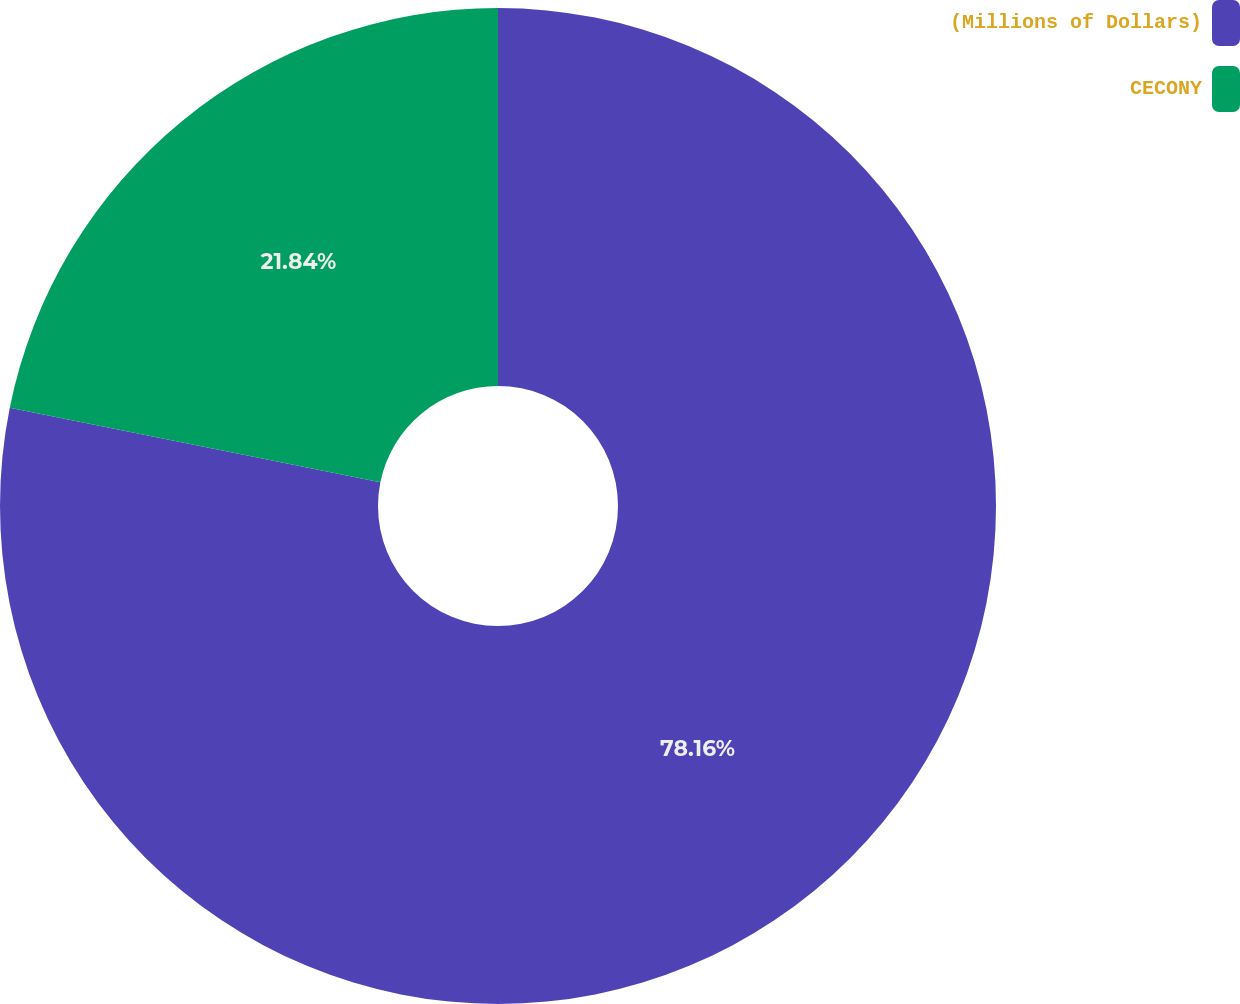Convert chart. <chart><loc_0><loc_0><loc_500><loc_500><pie_chart><fcel>(Millions of Dollars)<fcel>CECONY<nl><fcel>78.16%<fcel>21.84%<nl></chart> 